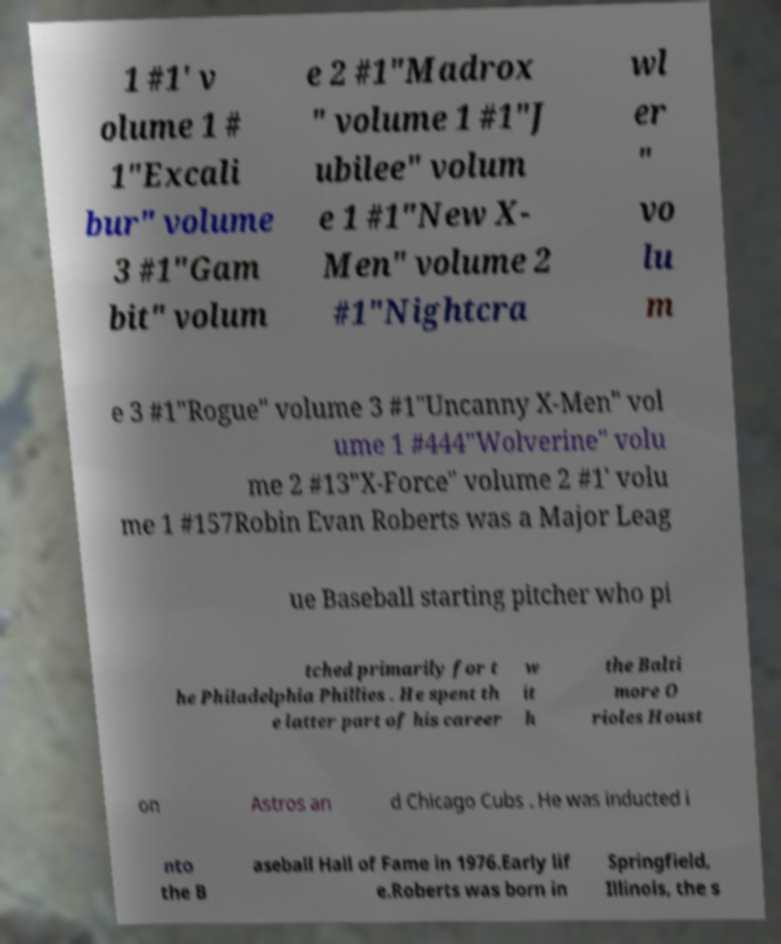There's text embedded in this image that I need extracted. Can you transcribe it verbatim? 1 #1' v olume 1 # 1"Excali bur" volume 3 #1"Gam bit" volum e 2 #1"Madrox " volume 1 #1"J ubilee" volum e 1 #1"New X- Men" volume 2 #1"Nightcra wl er " vo lu m e 3 #1"Rogue" volume 3 #1"Uncanny X-Men" vol ume 1 #444"Wolverine" volu me 2 #13"X-Force" volume 2 #1' volu me 1 #157Robin Evan Roberts was a Major Leag ue Baseball starting pitcher who pi tched primarily for t he Philadelphia Phillies . He spent th e latter part of his career w it h the Balti more O rioles Houst on Astros an d Chicago Cubs . He was inducted i nto the B aseball Hall of Fame in 1976.Early lif e.Roberts was born in Springfield, Illinois, the s 